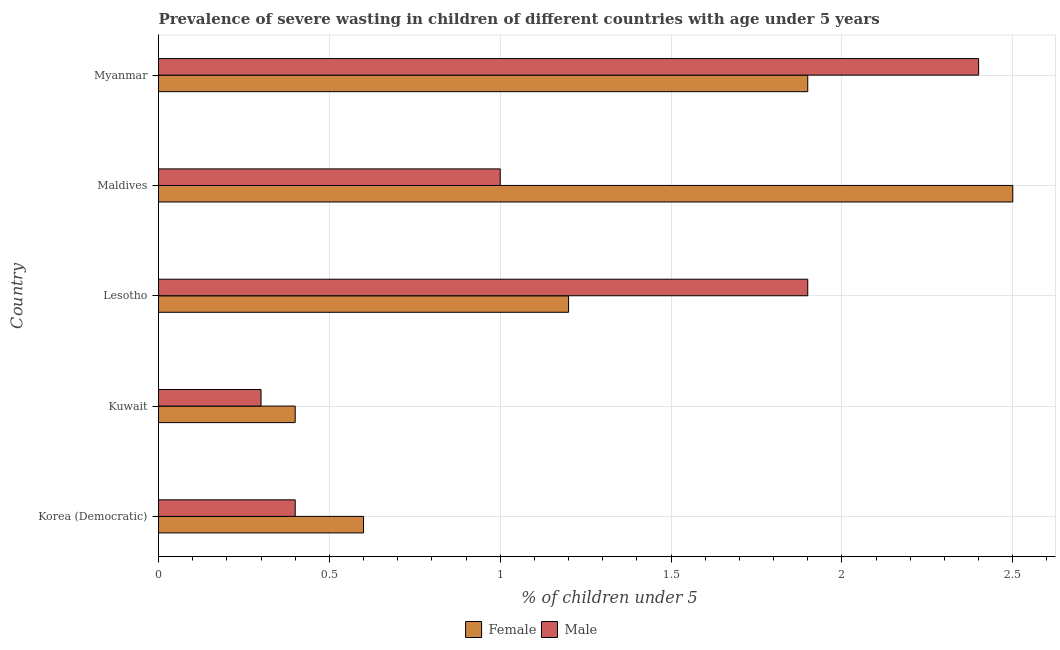How many different coloured bars are there?
Give a very brief answer. 2. Are the number of bars per tick equal to the number of legend labels?
Provide a short and direct response. Yes. How many bars are there on the 5th tick from the top?
Give a very brief answer. 2. How many bars are there on the 1st tick from the bottom?
Make the answer very short. 2. What is the label of the 3rd group of bars from the top?
Give a very brief answer. Lesotho. What is the percentage of undernourished female children in Lesotho?
Provide a succinct answer. 1.2. Across all countries, what is the maximum percentage of undernourished male children?
Keep it short and to the point. 2.4. Across all countries, what is the minimum percentage of undernourished male children?
Ensure brevity in your answer.  0.3. In which country was the percentage of undernourished male children maximum?
Give a very brief answer. Myanmar. In which country was the percentage of undernourished female children minimum?
Provide a short and direct response. Kuwait. What is the total percentage of undernourished male children in the graph?
Offer a terse response. 6. What is the difference between the percentage of undernourished male children in Lesotho and the percentage of undernourished female children in Maldives?
Your answer should be very brief. -0.6. What is the average percentage of undernourished female children per country?
Keep it short and to the point. 1.32. In how many countries, is the percentage of undernourished female children greater than 1.4 %?
Give a very brief answer. 2. What is the ratio of the percentage of undernourished male children in Lesotho to that in Myanmar?
Make the answer very short. 0.79. Is the difference between the percentage of undernourished male children in Korea (Democratic) and Lesotho greater than the difference between the percentage of undernourished female children in Korea (Democratic) and Lesotho?
Give a very brief answer. No. What is the difference between the highest and the second highest percentage of undernourished male children?
Your answer should be very brief. 0.5. What is the difference between the highest and the lowest percentage of undernourished male children?
Your answer should be very brief. 2.1. In how many countries, is the percentage of undernourished female children greater than the average percentage of undernourished female children taken over all countries?
Make the answer very short. 2. What does the 1st bar from the top in Maldives represents?
Provide a short and direct response. Male. What does the 1st bar from the bottom in Kuwait represents?
Offer a very short reply. Female. Does the graph contain any zero values?
Provide a short and direct response. No. Where does the legend appear in the graph?
Your response must be concise. Bottom center. What is the title of the graph?
Provide a short and direct response. Prevalence of severe wasting in children of different countries with age under 5 years. What is the label or title of the X-axis?
Your answer should be compact.  % of children under 5. What is the  % of children under 5 of Female in Korea (Democratic)?
Provide a short and direct response. 0.6. What is the  % of children under 5 of Male in Korea (Democratic)?
Your answer should be compact. 0.4. What is the  % of children under 5 in Female in Kuwait?
Offer a terse response. 0.4. What is the  % of children under 5 of Male in Kuwait?
Offer a terse response. 0.3. What is the  % of children under 5 in Female in Lesotho?
Provide a short and direct response. 1.2. What is the  % of children under 5 in Male in Lesotho?
Give a very brief answer. 1.9. What is the  % of children under 5 of Female in Maldives?
Offer a very short reply. 2.5. What is the  % of children under 5 of Male in Maldives?
Provide a short and direct response. 1. What is the  % of children under 5 of Female in Myanmar?
Offer a very short reply. 1.9. What is the  % of children under 5 of Male in Myanmar?
Your answer should be very brief. 2.4. Across all countries, what is the maximum  % of children under 5 of Female?
Ensure brevity in your answer.  2.5. Across all countries, what is the maximum  % of children under 5 in Male?
Give a very brief answer. 2.4. Across all countries, what is the minimum  % of children under 5 in Female?
Keep it short and to the point. 0.4. Across all countries, what is the minimum  % of children under 5 in Male?
Offer a very short reply. 0.3. What is the total  % of children under 5 in Male in the graph?
Ensure brevity in your answer.  6. What is the difference between the  % of children under 5 of Male in Korea (Democratic) and that in Lesotho?
Provide a short and direct response. -1.5. What is the difference between the  % of children under 5 of Female in Korea (Democratic) and that in Myanmar?
Provide a short and direct response. -1.3. What is the difference between the  % of children under 5 of Female in Kuwait and that in Lesotho?
Give a very brief answer. -0.8. What is the difference between the  % of children under 5 of Female in Kuwait and that in Maldives?
Provide a short and direct response. -2.1. What is the difference between the  % of children under 5 of Male in Kuwait and that in Maldives?
Ensure brevity in your answer.  -0.7. What is the difference between the  % of children under 5 in Male in Kuwait and that in Myanmar?
Your answer should be very brief. -2.1. What is the difference between the  % of children under 5 of Female in Maldives and that in Myanmar?
Make the answer very short. 0.6. What is the difference between the  % of children under 5 of Male in Maldives and that in Myanmar?
Your response must be concise. -1.4. What is the difference between the  % of children under 5 of Female in Korea (Democratic) and the  % of children under 5 of Male in Lesotho?
Provide a short and direct response. -1.3. What is the difference between the  % of children under 5 in Female in Kuwait and the  % of children under 5 in Male in Maldives?
Your answer should be very brief. -0.6. What is the difference between the  % of children under 5 of Female in Kuwait and the  % of children under 5 of Male in Myanmar?
Your answer should be very brief. -2. What is the difference between the  % of children under 5 in Female in Lesotho and the  % of children under 5 in Male in Maldives?
Ensure brevity in your answer.  0.2. What is the average  % of children under 5 of Female per country?
Make the answer very short. 1.32. What is the average  % of children under 5 of Male per country?
Provide a short and direct response. 1.2. What is the difference between the  % of children under 5 of Female and  % of children under 5 of Male in Korea (Democratic)?
Offer a very short reply. 0.2. What is the difference between the  % of children under 5 of Female and  % of children under 5 of Male in Lesotho?
Your answer should be very brief. -0.7. What is the difference between the  % of children under 5 of Female and  % of children under 5 of Male in Maldives?
Keep it short and to the point. 1.5. What is the ratio of the  % of children under 5 of Female in Korea (Democratic) to that in Kuwait?
Your response must be concise. 1.5. What is the ratio of the  % of children under 5 in Male in Korea (Democratic) to that in Lesotho?
Provide a succinct answer. 0.21. What is the ratio of the  % of children under 5 in Female in Korea (Democratic) to that in Maldives?
Ensure brevity in your answer.  0.24. What is the ratio of the  % of children under 5 in Female in Korea (Democratic) to that in Myanmar?
Offer a terse response. 0.32. What is the ratio of the  % of children under 5 in Male in Korea (Democratic) to that in Myanmar?
Your response must be concise. 0.17. What is the ratio of the  % of children under 5 in Male in Kuwait to that in Lesotho?
Your answer should be very brief. 0.16. What is the ratio of the  % of children under 5 of Female in Kuwait to that in Maldives?
Offer a terse response. 0.16. What is the ratio of the  % of children under 5 of Female in Kuwait to that in Myanmar?
Offer a very short reply. 0.21. What is the ratio of the  % of children under 5 in Female in Lesotho to that in Maldives?
Provide a succinct answer. 0.48. What is the ratio of the  % of children under 5 in Male in Lesotho to that in Maldives?
Your answer should be compact. 1.9. What is the ratio of the  % of children under 5 of Female in Lesotho to that in Myanmar?
Give a very brief answer. 0.63. What is the ratio of the  % of children under 5 in Male in Lesotho to that in Myanmar?
Make the answer very short. 0.79. What is the ratio of the  % of children under 5 of Female in Maldives to that in Myanmar?
Offer a very short reply. 1.32. What is the ratio of the  % of children under 5 of Male in Maldives to that in Myanmar?
Your response must be concise. 0.42. What is the difference between the highest and the lowest  % of children under 5 of Female?
Provide a succinct answer. 2.1. 